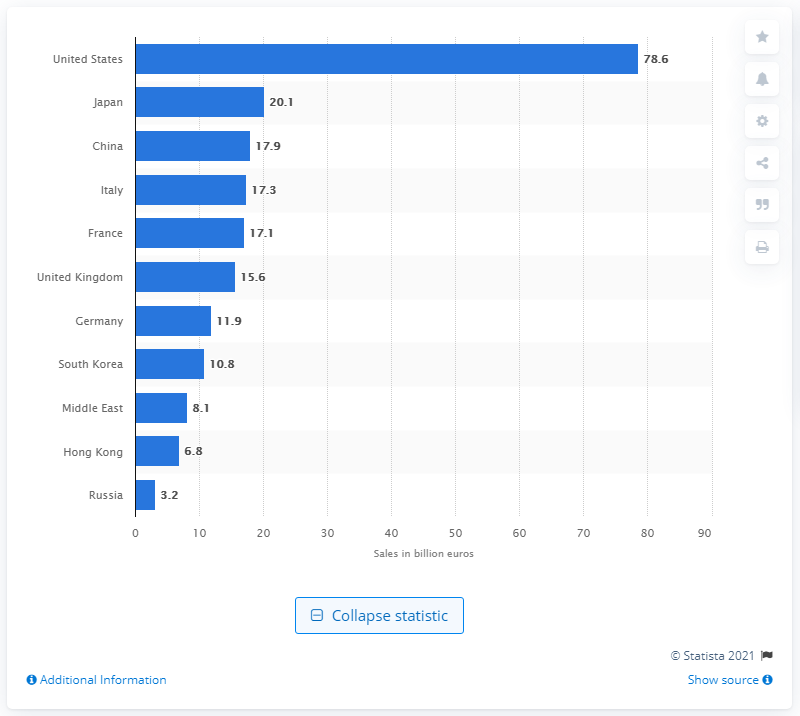List a handful of essential elements in this visual. According to estimates, the luxury goods industry was valued at approximately 78.6 billion dollars in 2015. 